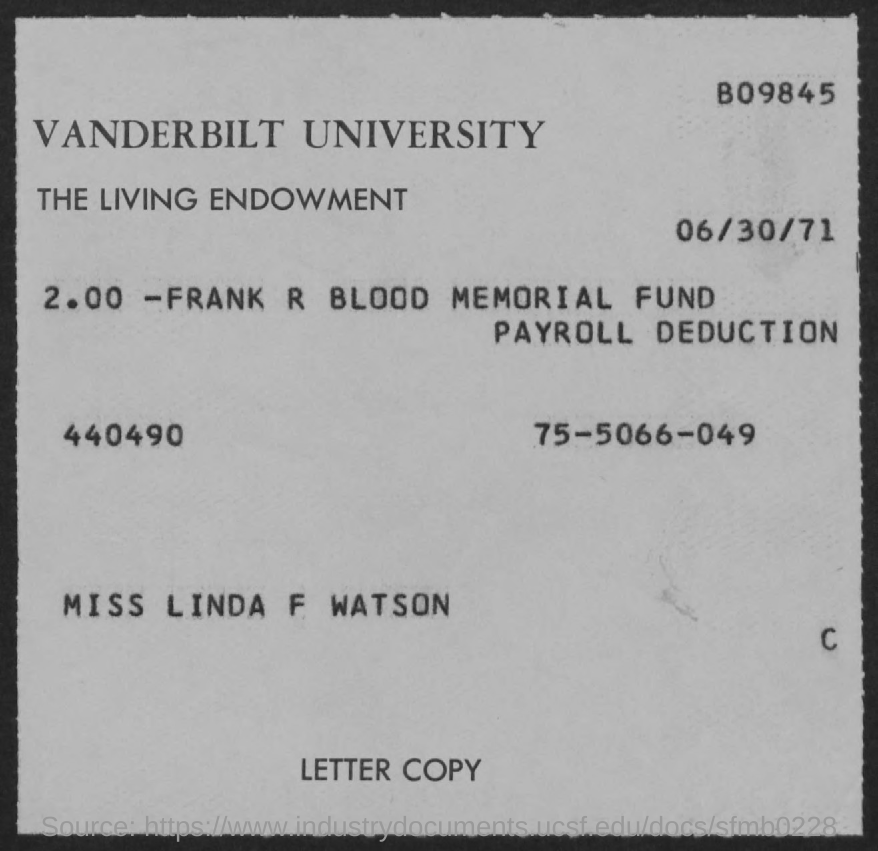Highlight a few significant elements in this photo. The date mentioned in this document is June 30, 1971. Vanderbilt University is mentioned in the document. 